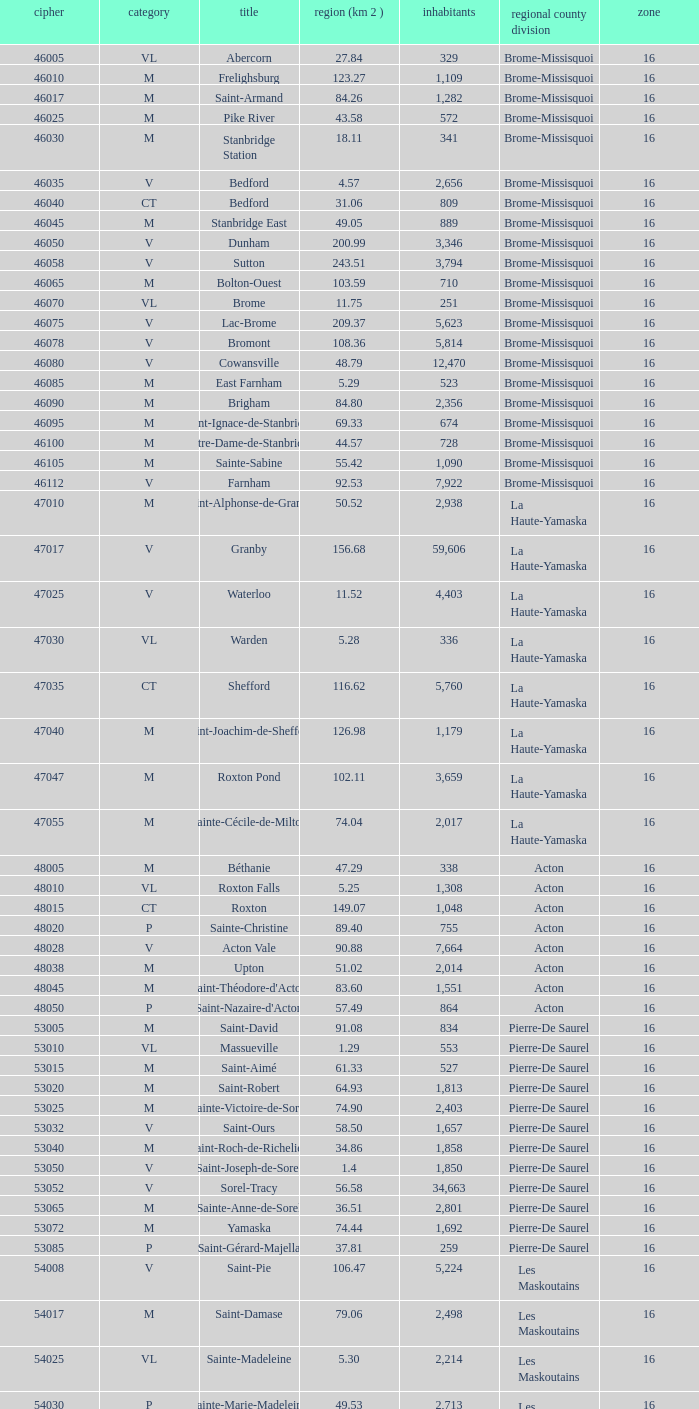What is the code for a Le Haut-Saint-Laurent municipality that has 16 or more regions? None. 